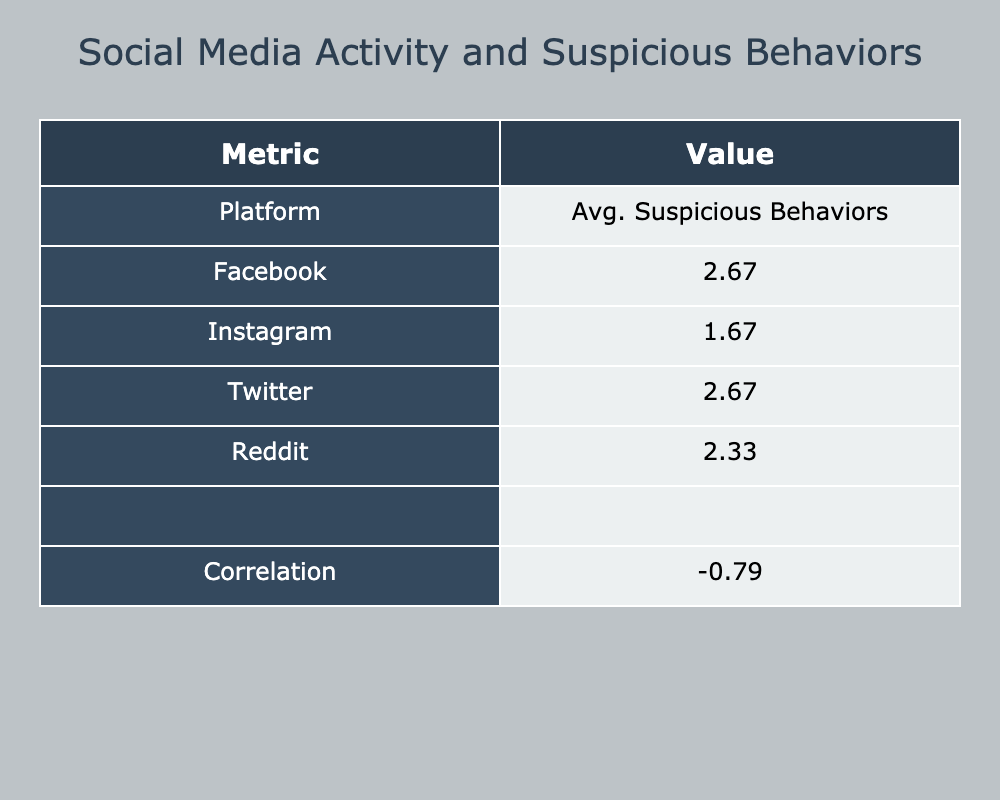What is the average number of reported suspicious behaviors for users on Instagram? To find the average number of reported suspicious behaviors for Instagram, we look at the value in the table under 'Avg. Suspicious Behaviors' for the 'Instagram' platform, which is 2.33.
Answer: 2.33 Which platform has the highest average number of reported suspicious behaviors? By comparing the averages listed for each platform in the table, 'Twitter' has the highest average with 3.00 reported suspicious behaviors.
Answer: Twitter Is the correlation between social media activity and reported suspicious behaviors positive? The correlation value given in the table is -0.41, which indicates a negative correlation between social media activity and reported suspicious behaviors, meaning higher activity is associated with fewer reported suspicious behaviors.
Answer: No What is the difference in average reported suspicious behaviors between Facebook and Reddit? The average for Facebook is 2.33 and for Reddit is 3.00. The difference is calculated by subtracting these two values: 3.00 - 2.33 = 0.67.
Answer: 0.67 Do females have a higher reported suspicious behavior average compared to males? We can see from the platform averages that the overall averages for males is 2.25 and for females is 2.67, indicating that females have a higher average reported suspicious behaviors.
Answer: Yes What is the total of reported suspicious behaviors across all platforms? By adding the averages given for all platforms: 2.33 (Facebook) + 2.33 (Instagram) + 3.00 (Twitter) + 3.00 (Reddit) = 10.67.
Answer: 10.67 How does the average reported suspicious behavior on Facebook compare to the overall average across all platforms? The average of suspicious behaviors on Facebook is 2.33. The total across all platforms is 2.67 (10.67 total behaviors divided by 4 platforms), which means Facebook's average is lower than the overall average.
Answer: Lower Is there any platform with an average lower than 2 reported suspicious behaviors? We can check the averages listed in the table: Facebook (2.33), Instagram (2.33), Twitter (3.00), and Reddit (3.00) - none of these platforms have averages below 2.
Answer: No 